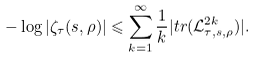Convert formula to latex. <formula><loc_0><loc_0><loc_500><loc_500>- \log | \zeta _ { \tau } ( s , \rho ) | \leqslant \sum _ { k = 1 } ^ { \infty } \frac { 1 } { k } | t r ( \mathcal { L } _ { \tau , s , \rho } ^ { 2 k } ) | .</formula> 